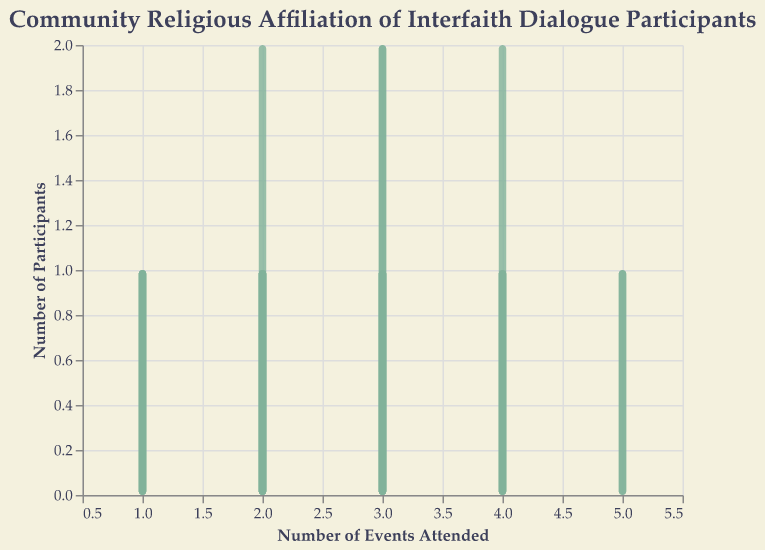How many participants attended 5 events? From the figure, we can see distinct bars representing the number of participants for each number of events attended. Locate the bar for 5 events and check the y-axis value.
Answer: 2 What's the total number of participants who attended 2 events? Look at the bar representing 2 events. The height of the bar on the y-axis indicates the count of participants who attended 2 events.
Answer: 5 Which religious affiliation had the highest number of attendees at single events? Identify the bars associated with 1 event and look at the tooltip or use the color-coded bars to see which religion has the highest count.
Answer: Buddhism and Sikhism Compare Christianity and Judaism participants: which had more participants attending 3 events? Locate the bars for 3 events on the x-axis; then, identify the bars corresponding to Christianity and Judaism, and compare their heights.
Answer: Christianity What's the average number of events attended across all participants? Summarize the total number of events attended (5+3+2+4+1+1+4+2+3+2+3+2+3+4+1+3+2+3+4+3+2+1+3+4+2+5), count the number of participants (26), and divide the total by the number of participants.
Answer: 2.92 Which religious group collectively attended the most events? Sum up the events attended by participants within each religious group. Compare the totals: Christianity (5+4+3+4+2=18), Islam (3+2+4+3+5=17), Judaism (2+3+1+2+2=10), Hinduism (4+2+3+1=10), Buddhism (1+3+2+3=9), Sikhism (1+2+3+4=10).
Answer: Christianity How many distinct event attendance counts are present in the data? Identify the different x-axis values where bars are present.
Answer: 5 What is the median number of events attended by Buddhist participants? For Buddhist participants, list their events attended (1, 3, 2, 3), sort them in ascending order (1, 2, 3, 3), and find the median value (average of 2 and 3 as middle values).
Answer: 2.5 